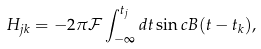<formula> <loc_0><loc_0><loc_500><loc_500>H _ { j k } = - 2 \pi \mathcal { F } \int _ { - \infty } ^ { t _ { j } } d t \sin c B ( t - t _ { k } ) ,</formula> 